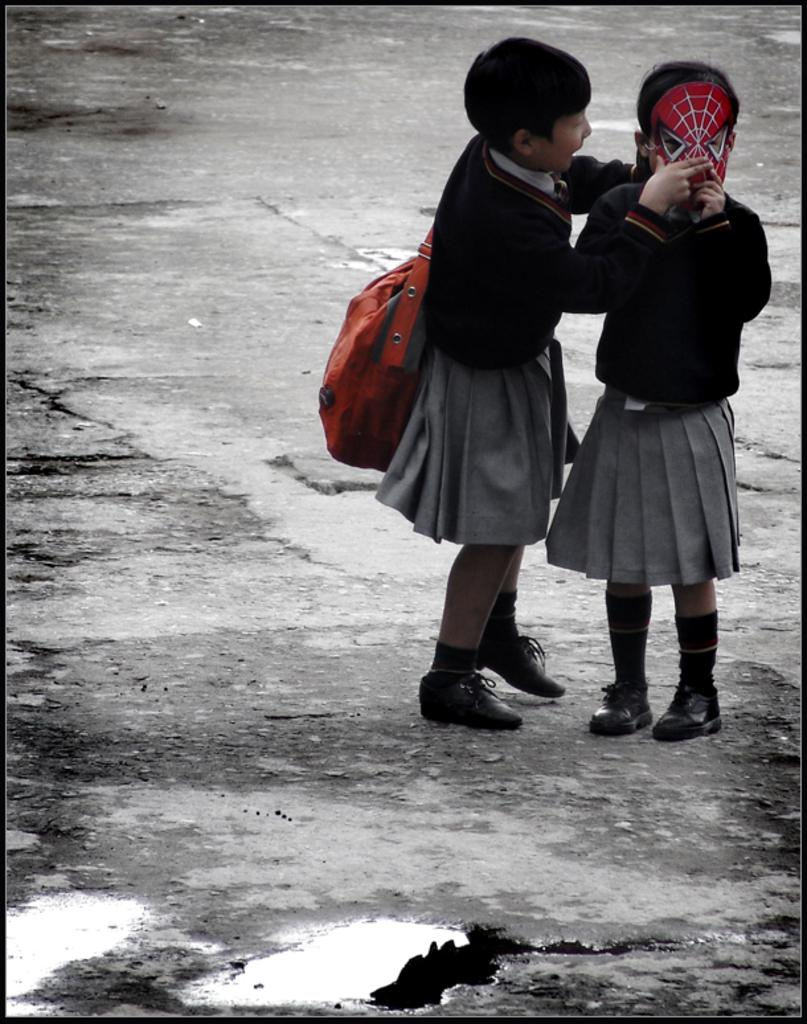How many children are present in the image? There are two children in the image. What is one child wearing in the image? One child is wearing a face mask. What is the other child carrying in the image? The other child is carrying a bag. What type of linen is being used to cover the bikes in the image? There are no bikes present in the image, and therefore no linen is being used to cover them. 